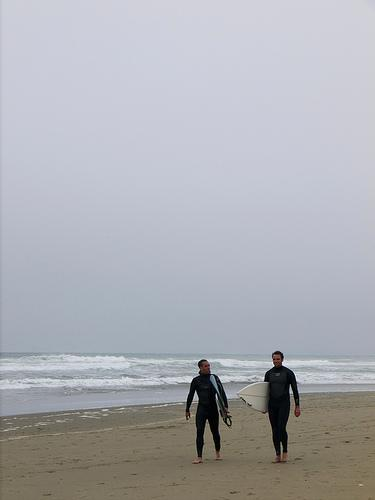How many surfers are in the image, and can you describe their position? There are two surfers in the image, one on the left carrying a blue surfboard and one on the right carrying a white surfboard. What is the most dominant weather feature in the sky? In the sky, white clouds are the most dominant weather feature. What can be observed on the sand in the image? Footprints and wet brown beach sand can be observed in the image. What can you infer about the relationship between the two men carrying surfboards? Based on the image, we can infer that the two men carrying surfboards might be friends or surfing partners. Count the total number of surfboards in the image. There are two surfboards in the image, one white and one blue. Assess the overall quality of the image. The overall quality of the image is good, with clear details and well-captured objects. What is the color of the surfboard that the man on the right is carrying? The man on the right is carrying a white surfboard. What kind of clothing are the two men on the beach wearing? The two men on the beach are wearing black wet suits. Describe the sentiment or mood portrayed in the image. The sentiment portrayed in the image is adventurous and active, as two men are preparing to surf in rough ocean waves. Describe the condition of the ocean in the image. The ocean appears rough with large waves crashing to shore and white ocean wave crests. 